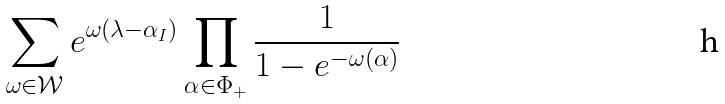Convert formula to latex. <formula><loc_0><loc_0><loc_500><loc_500>\sum _ { \omega \in \mathcal { W } } e ^ { \omega ( \lambda - \alpha _ { I } ) } \prod _ { \alpha \in \Phi _ { + } } \frac { 1 } { 1 - e ^ { - \omega ( \alpha ) } }</formula> 